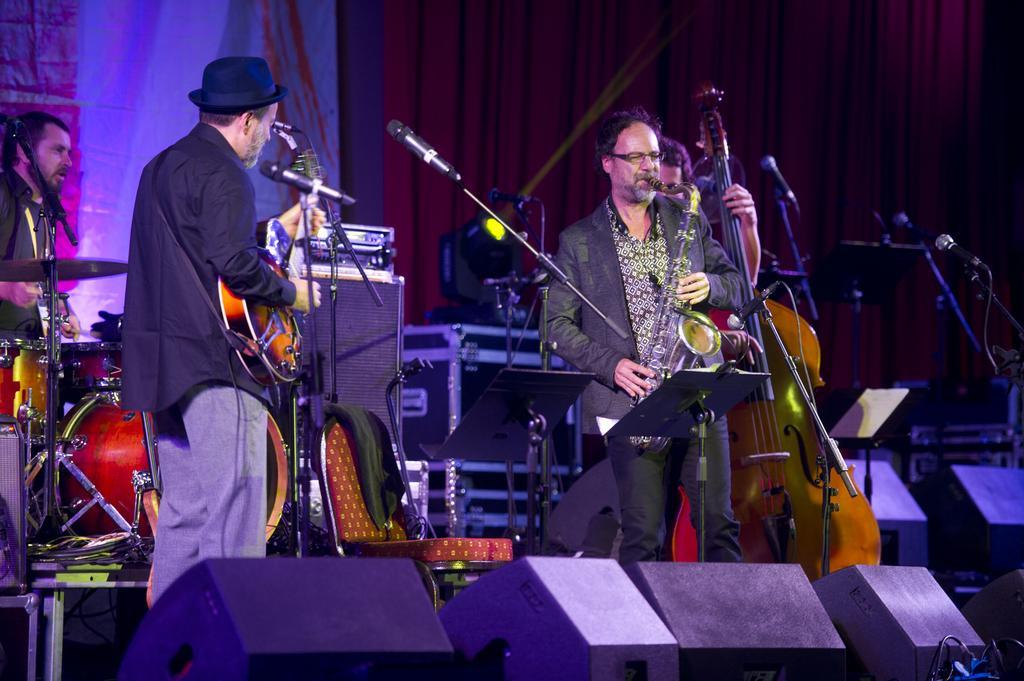How would you summarize this image in a sentence or two? A person wearing a black coat and a hat is holding guitar and playing. Another person holding another musical instrument and playing. In the back another person is playing drums. Also in the back a person is playing a big violin. There are some instruments kept in the back. There is a chair. In the front there are speakers. In the background there is a red curtain. Also there are many mics and mic stands. 